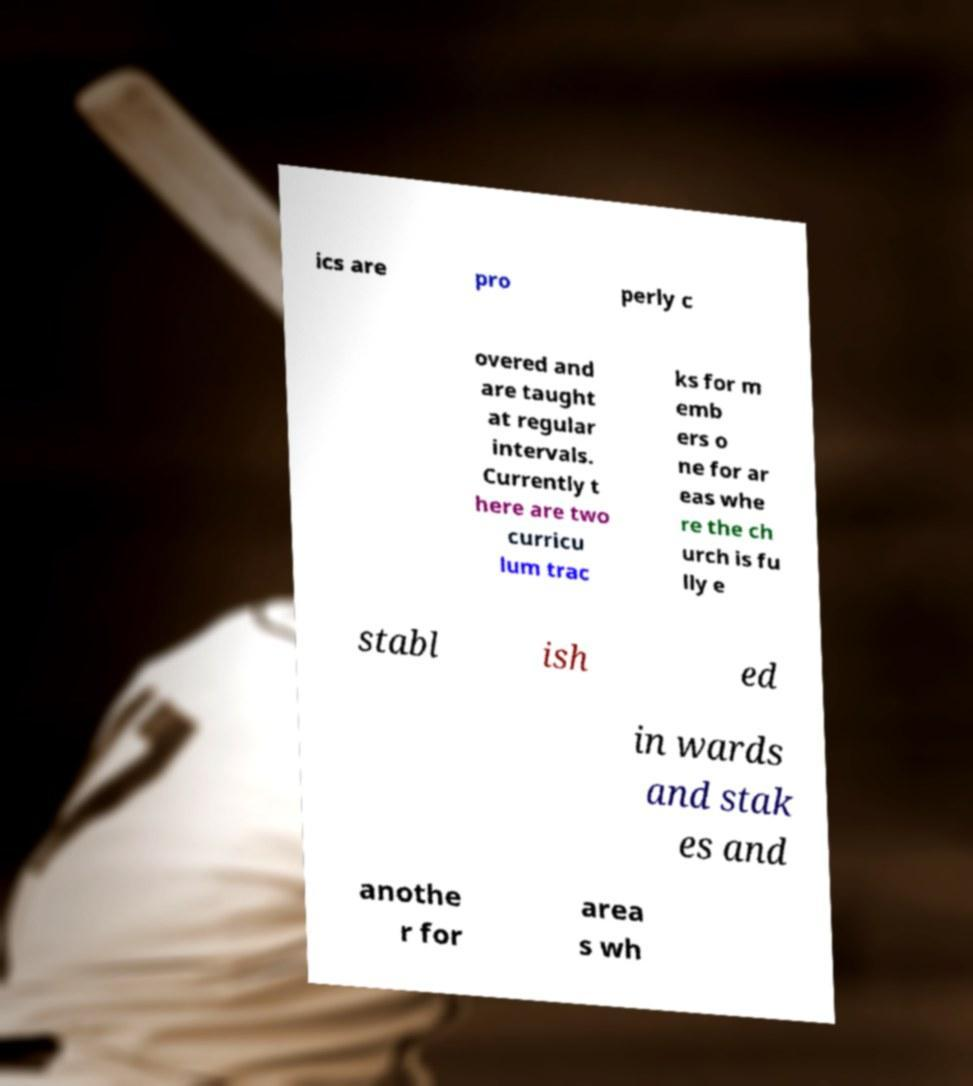What messages or text are displayed in this image? I need them in a readable, typed format. ics are pro perly c overed and are taught at regular intervals. Currently t here are two curricu lum trac ks for m emb ers o ne for ar eas whe re the ch urch is fu lly e stabl ish ed in wards and stak es and anothe r for area s wh 